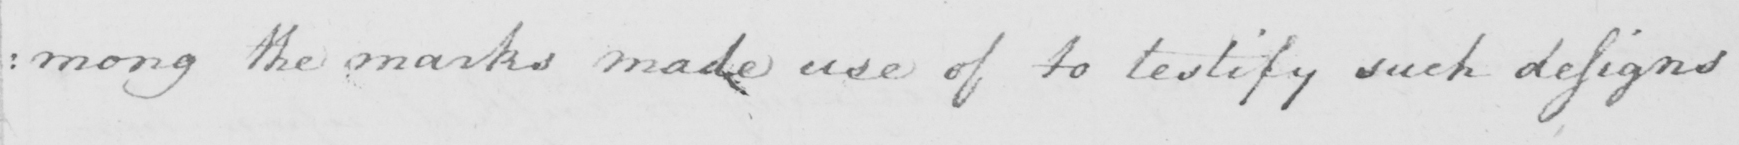Can you read and transcribe this handwriting? : mong the marks made use of to testify such designs 